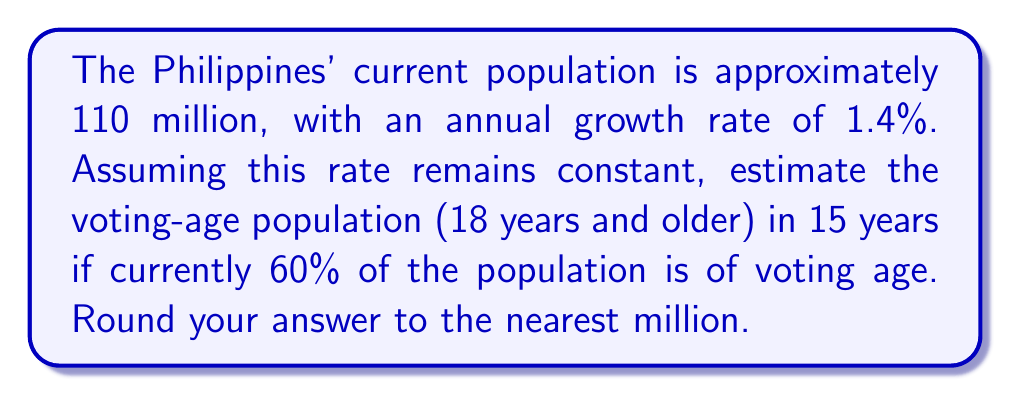What is the answer to this math problem? Let's break this down step-by-step:

1) First, calculate the total population after 15 years:
   - Use the compound growth formula: $A = P(1 + r)^t$
   - Where A is final amount, P is initial principal, r is annual rate, t is time in years
   - $A = 110,000,000 * (1 + 0.014)^{15}$
   - $A = 110,000,000 * 1.230965$
   - $A = 135,406,150$

2) Now, we need to find the voting-age population:
   - Currently, 60% of 110 million = 66 million are of voting age
   - Assume this proportion remains constant

3) Calculate 60% of the new total population:
   - $135,406,150 * 0.60 = 81,243,690$

4) Round to the nearest million:
   - 81,243,690 rounds to 81 million
Answer: 81 million 